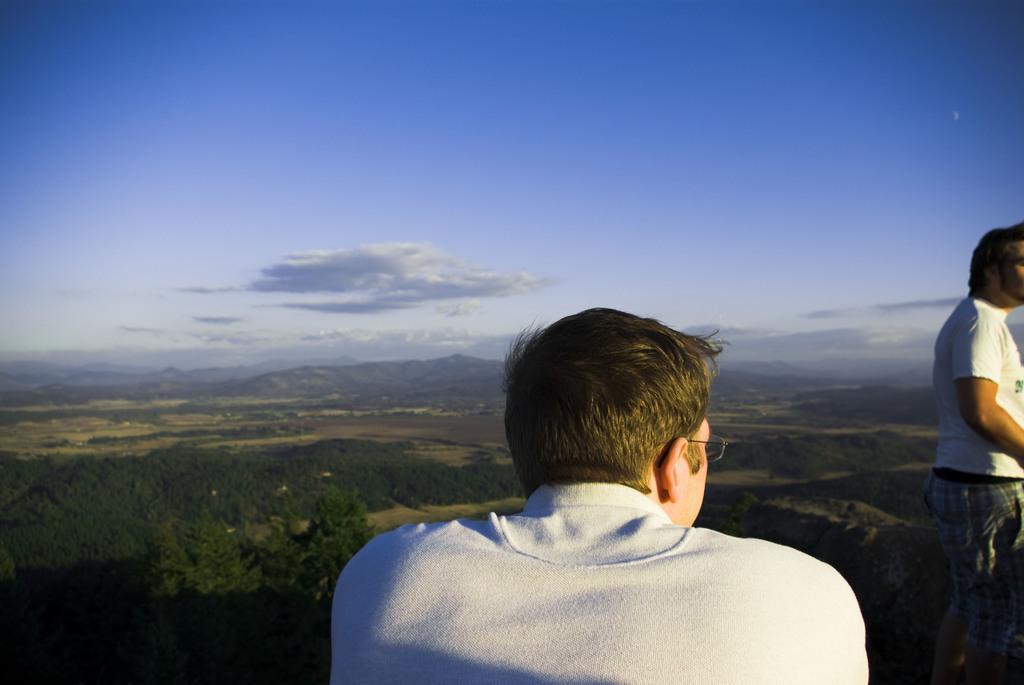How would you summarize this image in a sentence or two? In this picture there is a boy in the center of the image and there is another boy on the right side of the image, there is greenery in the background area of the image and there is sky at the top side of the image. 